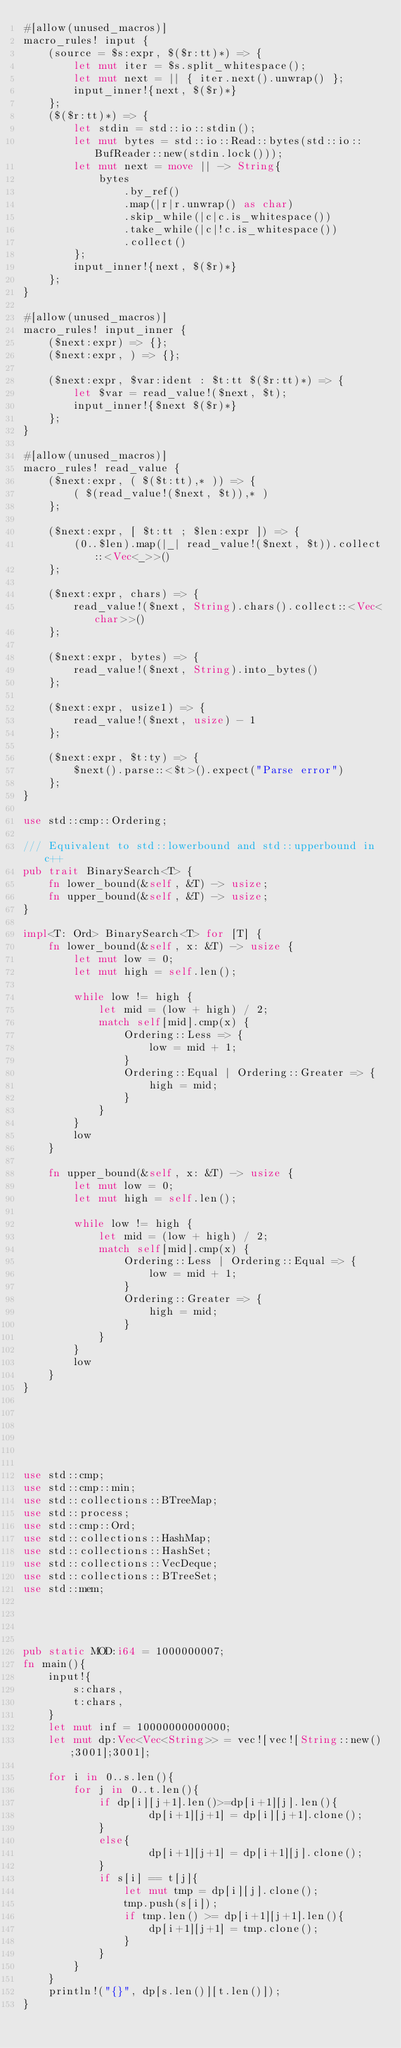Convert code to text. <code><loc_0><loc_0><loc_500><loc_500><_Rust_>#[allow(unused_macros)]
macro_rules! input {
    (source = $s:expr, $($r:tt)*) => {
        let mut iter = $s.split_whitespace();
        let mut next = || { iter.next().unwrap() };
        input_inner!{next, $($r)*}
    };
    ($($r:tt)*) => {
        let stdin = std::io::stdin();
        let mut bytes = std::io::Read::bytes(std::io::BufReader::new(stdin.lock()));
        let mut next = move || -> String{
            bytes
                .by_ref()
                .map(|r|r.unwrap() as char)
                .skip_while(|c|c.is_whitespace())
                .take_while(|c|!c.is_whitespace())
                .collect()
        };
        input_inner!{next, $($r)*}
    };
}
 
#[allow(unused_macros)]
macro_rules! input_inner {
    ($next:expr) => {};
    ($next:expr, ) => {};
 
    ($next:expr, $var:ident : $t:tt $($r:tt)*) => {
        let $var = read_value!($next, $t);
        input_inner!{$next $($r)*}
    };
}
 
#[allow(unused_macros)]
macro_rules! read_value {
    ($next:expr, ( $($t:tt),* )) => {
        ( $(read_value!($next, $t)),* )
    };
 
    ($next:expr, [ $t:tt ; $len:expr ]) => {
        (0..$len).map(|_| read_value!($next, $t)).collect::<Vec<_>>()
    };
 
    ($next:expr, chars) => {
        read_value!($next, String).chars().collect::<Vec<char>>()
    };
 
    ($next:expr, bytes) => {
        read_value!($next, String).into_bytes()
    };
 
    ($next:expr, usize1) => {
        read_value!($next, usize) - 1
    };
 
    ($next:expr, $t:ty) => {
        $next().parse::<$t>().expect("Parse error")
    };
}
 
use std::cmp::Ordering;
 
/// Equivalent to std::lowerbound and std::upperbound in c++
pub trait BinarySearch<T> {
    fn lower_bound(&self, &T) -> usize;
    fn upper_bound(&self, &T) -> usize;
}
 
impl<T: Ord> BinarySearch<T> for [T] {
    fn lower_bound(&self, x: &T) -> usize {
        let mut low = 0;
        let mut high = self.len();
 
        while low != high {
            let mid = (low + high) / 2;
            match self[mid].cmp(x) {
                Ordering::Less => {
                    low = mid + 1;
                }
                Ordering::Equal | Ordering::Greater => {
                    high = mid;
                }
            }
        }
        low
    }
 
    fn upper_bound(&self, x: &T) -> usize {
        let mut low = 0;
        let mut high = self.len();
 
        while low != high {
            let mid = (low + high) / 2;
            match self[mid].cmp(x) {
                Ordering::Less | Ordering::Equal => {
                    low = mid + 1;
                }
                Ordering::Greater => {
                    high = mid;
                }
            }
        }
        low
    }
}
 
 
 
 
 
 
use std::cmp;
use std::cmp::min;
use std::collections::BTreeMap;
use std::process;
use std::cmp::Ord;
use std::collections::HashMap;
use std::collections::HashSet;
use std::collections::VecDeque;
use std::collections::BTreeSet;
use std::mem;



 
pub static MOD:i64 = 1000000007;
fn main(){
    input!{
        s:chars,
        t:chars,
    }
    let mut inf = 10000000000000;
    let mut dp:Vec<Vec<String>> = vec![vec![String::new();3001];3001];

    for i in 0..s.len(){
        for j in 0..t.len(){
            if dp[i][j+1].len()>=dp[i+1][j].len(){
                    dp[i+1][j+1] = dp[i][j+1].clone();
            }
            else{
                    dp[i+1][j+1] = dp[i+1][j].clone();
            }
            if s[i] == t[j]{
                let mut tmp = dp[i][j].clone();
                tmp.push(s[i]);
                if tmp.len() >= dp[i+1][j+1].len(){
                    dp[i+1][j+1] = tmp.clone();
                }
            }
        }
    }
    println!("{}", dp[s.len()][t.len()]);
}

</code> 